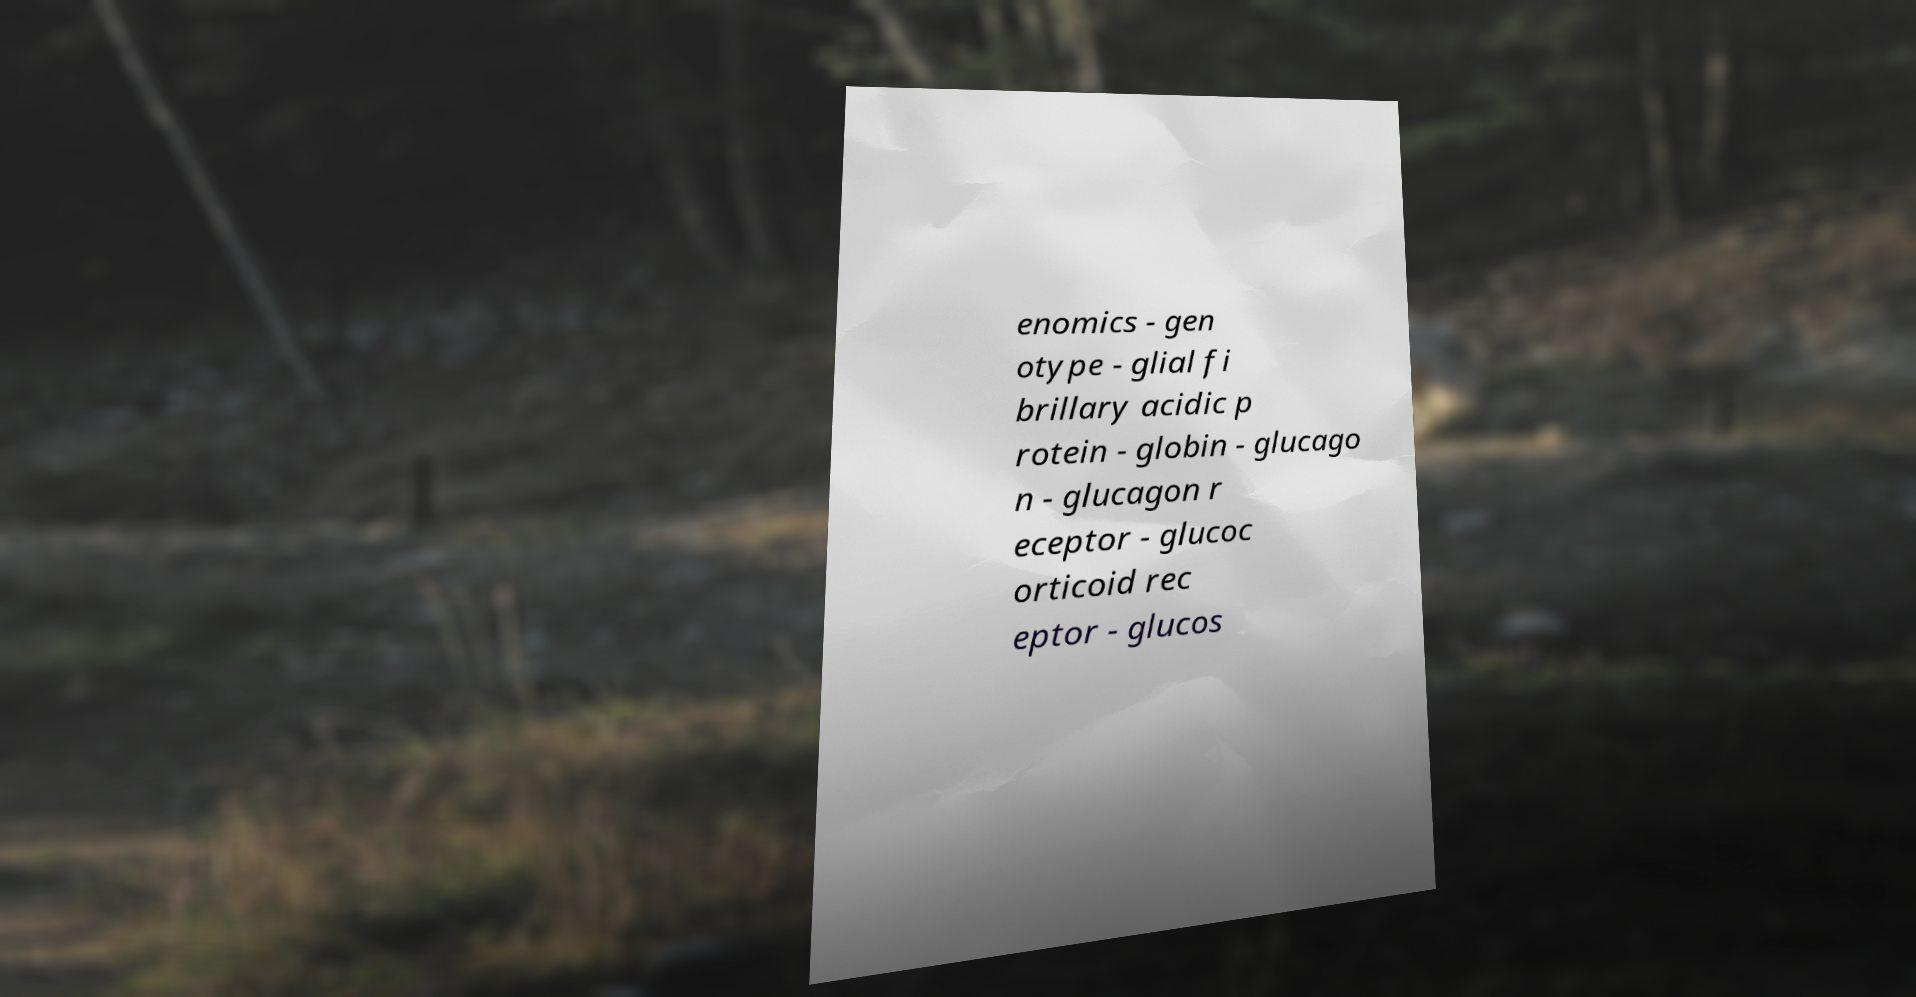Please read and relay the text visible in this image. What does it say? enomics - gen otype - glial fi brillary acidic p rotein - globin - glucago n - glucagon r eceptor - glucoc orticoid rec eptor - glucos 